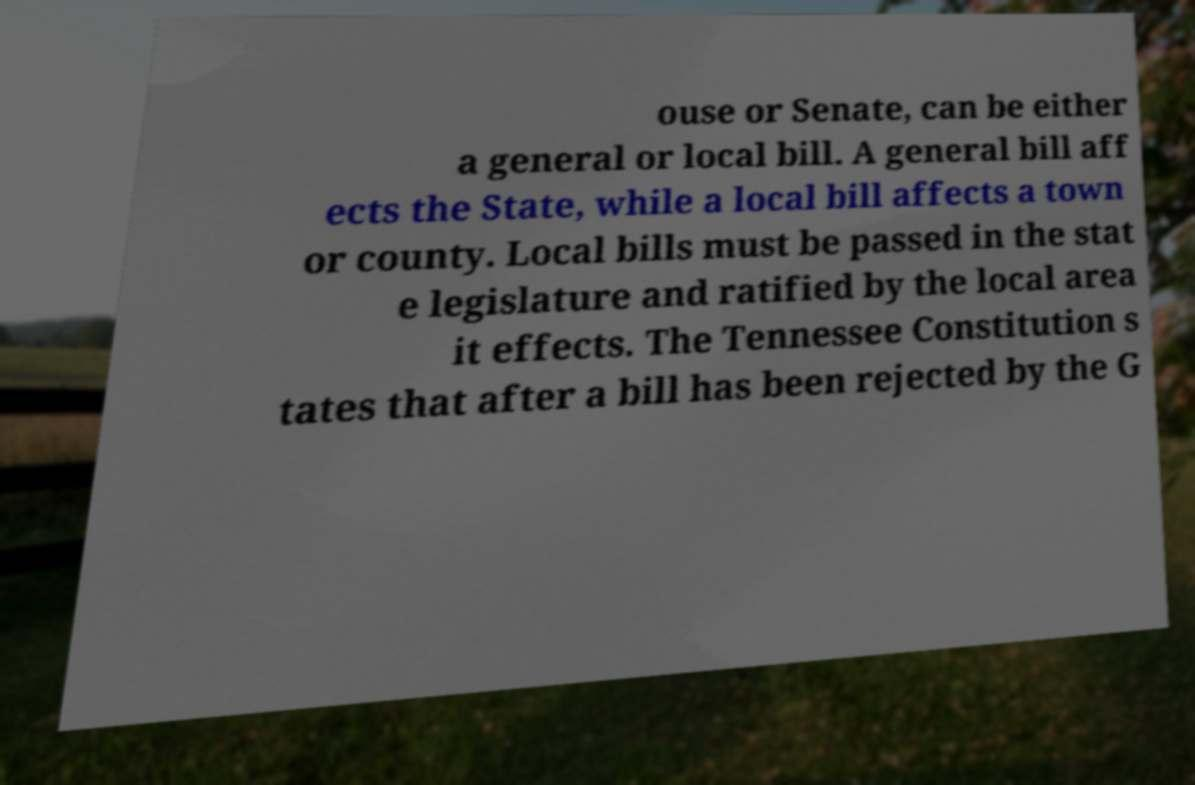Please identify and transcribe the text found in this image. ouse or Senate, can be either a general or local bill. A general bill aff ects the State, while a local bill affects a town or county. Local bills must be passed in the stat e legislature and ratified by the local area it effects. The Tennessee Constitution s tates that after a bill has been rejected by the G 